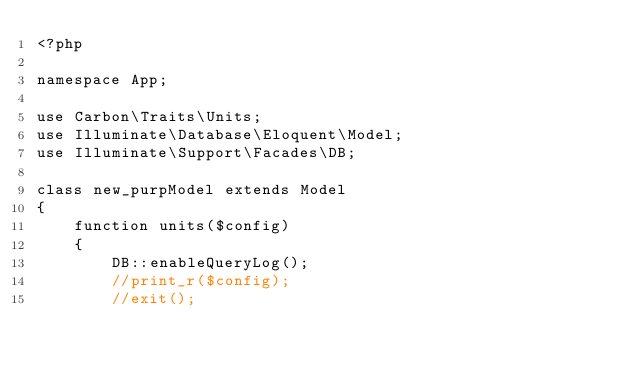Convert code to text. <code><loc_0><loc_0><loc_500><loc_500><_PHP_><?php

namespace App;

use Carbon\Traits\Units;
use Illuminate\Database\Eloquent\Model;
use Illuminate\Support\Facades\DB;

class new_purpModel extends Model
{
    function units($config)
    {
        DB::enableQueryLog();
        //print_r($config);
        //exit();
</code> 